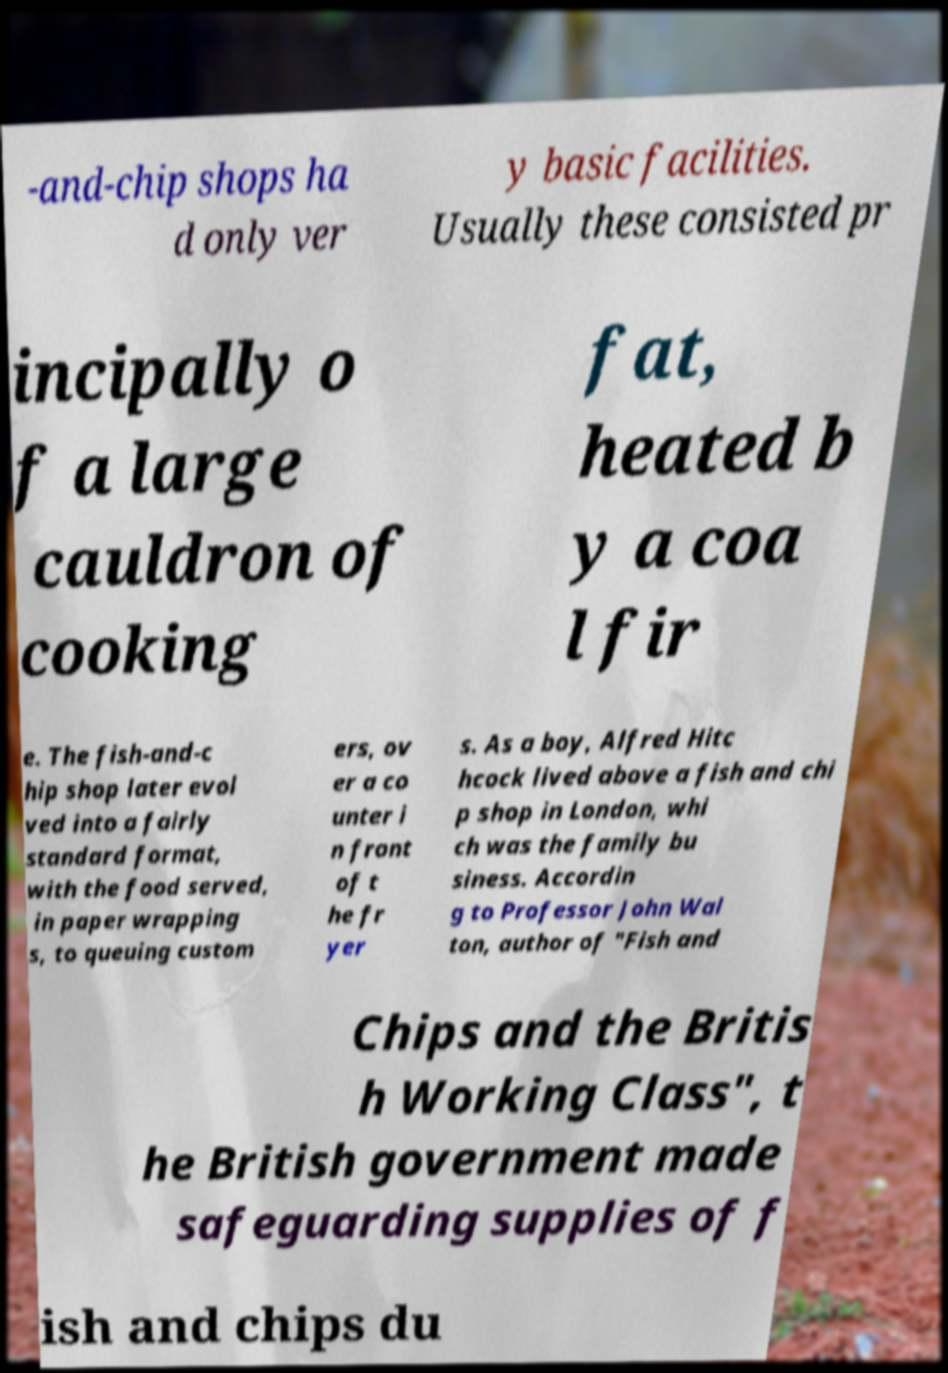Can you read and provide the text displayed in the image?This photo seems to have some interesting text. Can you extract and type it out for me? -and-chip shops ha d only ver y basic facilities. Usually these consisted pr incipally o f a large cauldron of cooking fat, heated b y a coa l fir e. The fish-and-c hip shop later evol ved into a fairly standard format, with the food served, in paper wrapping s, to queuing custom ers, ov er a co unter i n front of t he fr yer s. As a boy, Alfred Hitc hcock lived above a fish and chi p shop in London, whi ch was the family bu siness. Accordin g to Professor John Wal ton, author of "Fish and Chips and the Britis h Working Class", t he British government made safeguarding supplies of f ish and chips du 